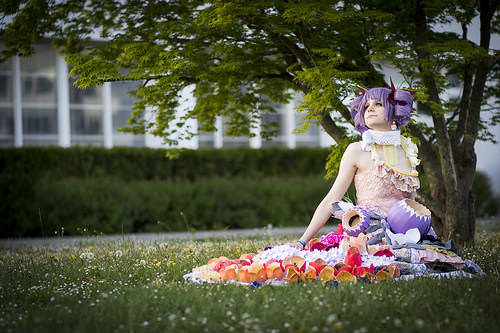<image>
Can you confirm if the girl is in the grass? Yes. The girl is contained within or inside the grass, showing a containment relationship. 